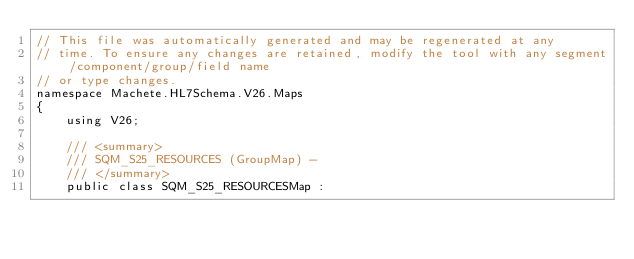<code> <loc_0><loc_0><loc_500><loc_500><_C#_>// This file was automatically generated and may be regenerated at any
// time. To ensure any changes are retained, modify the tool with any segment/component/group/field name
// or type changes.
namespace Machete.HL7Schema.V26.Maps
{
    using V26;

    /// <summary>
    /// SQM_S25_RESOURCES (GroupMap) - 
    /// </summary>
    public class SQM_S25_RESOURCESMap :</code> 